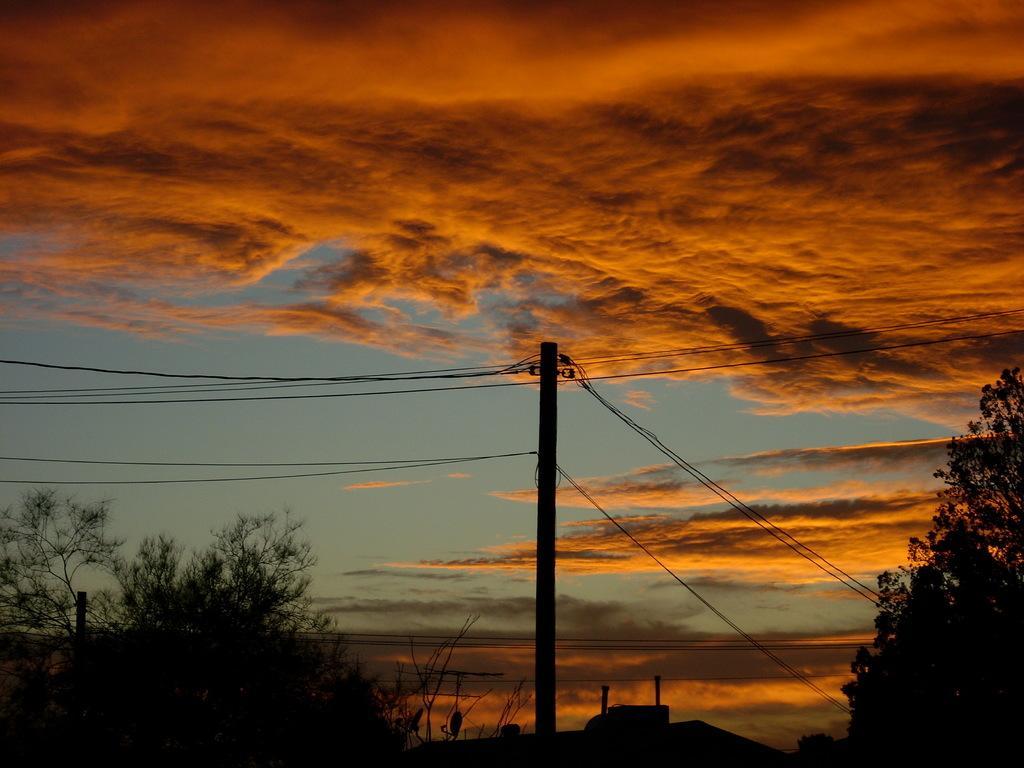Please provide a concise description of this image. In the foreground of the image we can see a pole and wires. Background of the image, the blue color sky is there with clouds. We can see trees in the right and left bottom of the image. One house roof is there at the bottom of the image. 